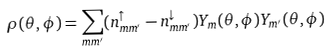Convert formula to latex. <formula><loc_0><loc_0><loc_500><loc_500>\rho ( \theta , \phi ) = \sum _ { m m ^ { \prime } } ( n _ { m m ^ { \prime } } ^ { \uparrow } - n _ { m m ^ { \prime } } ^ { \downarrow } ) Y _ { m } ( \theta , \phi ) Y _ { m ^ { \prime } } ( \theta , \phi )</formula> 